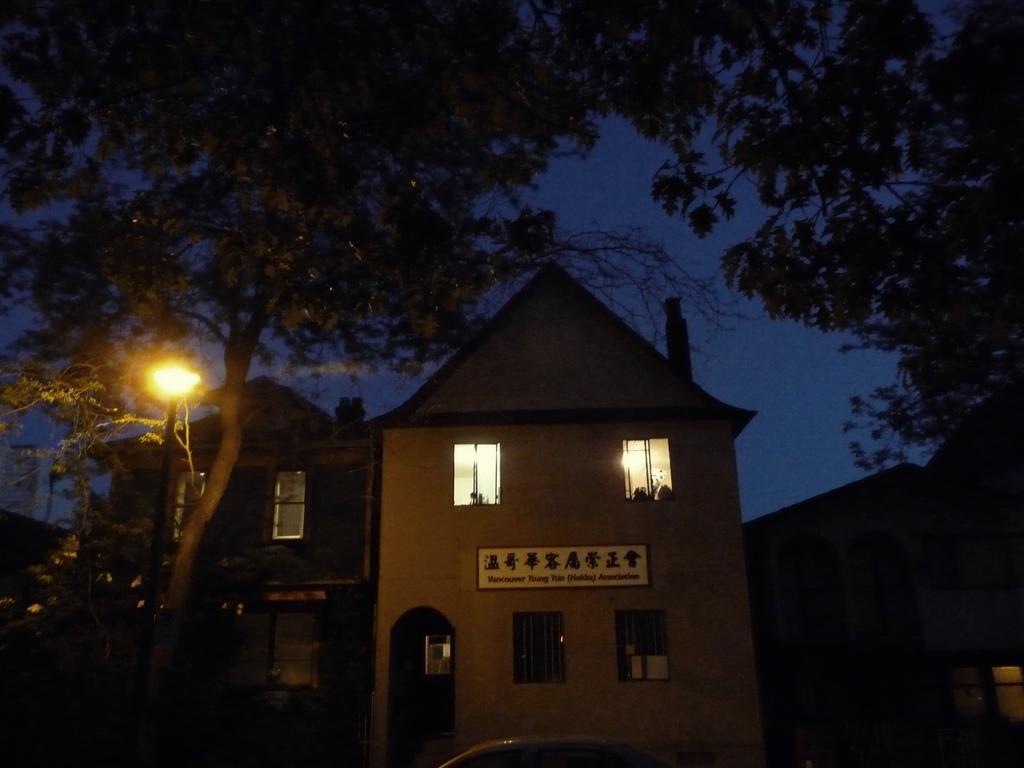In one or two sentences, can you explain what this image depicts? This image is taken in the nighttime. In this image there is a building in the middle and there are trees on either side of it. On the left side there is a light. At the top there is the sky. 